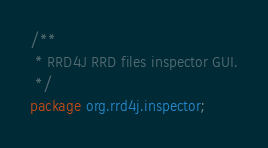Convert code to text. <code><loc_0><loc_0><loc_500><loc_500><_Java_>/**
 * RRD4J RRD files inspector GUI.
 */
package org.rrd4j.inspector;
</code> 